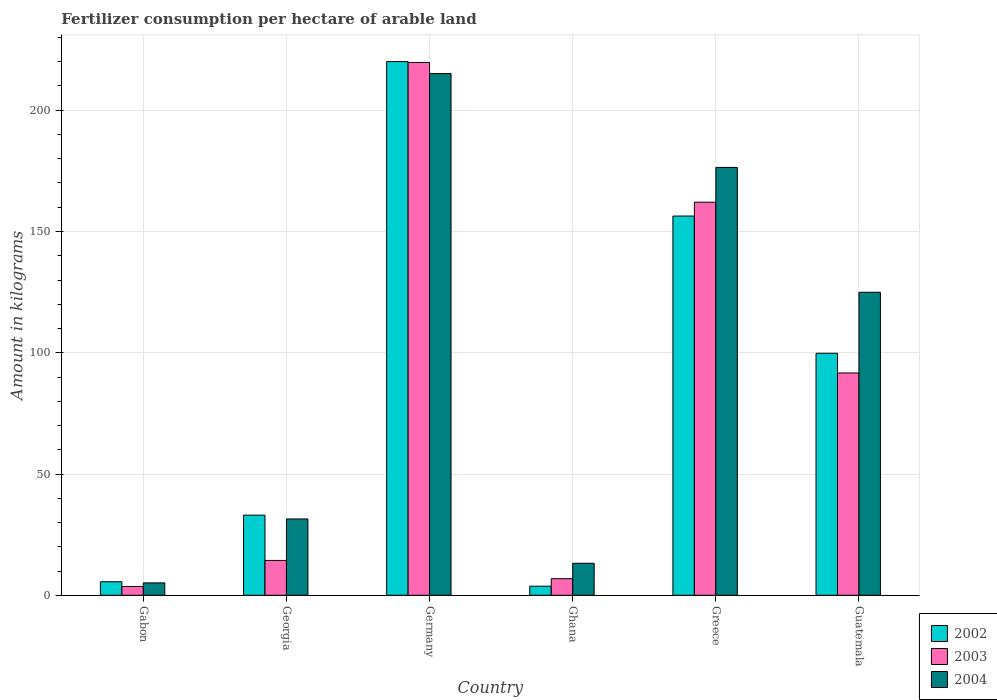How many different coloured bars are there?
Provide a succinct answer. 3. How many groups of bars are there?
Keep it short and to the point. 6. Are the number of bars on each tick of the X-axis equal?
Your response must be concise. Yes. What is the label of the 6th group of bars from the left?
Offer a terse response. Guatemala. What is the amount of fertilizer consumption in 2002 in Ghana?
Offer a terse response. 3.75. Across all countries, what is the maximum amount of fertilizer consumption in 2003?
Your answer should be compact. 219.7. Across all countries, what is the minimum amount of fertilizer consumption in 2003?
Keep it short and to the point. 3.61. In which country was the amount of fertilizer consumption in 2002 minimum?
Ensure brevity in your answer.  Ghana. What is the total amount of fertilizer consumption in 2004 in the graph?
Provide a short and direct response. 566.26. What is the difference between the amount of fertilizer consumption in 2004 in Georgia and that in Guatemala?
Your answer should be compact. -93.48. What is the difference between the amount of fertilizer consumption in 2004 in Ghana and the amount of fertilizer consumption in 2003 in Germany?
Offer a terse response. -206.5. What is the average amount of fertilizer consumption in 2002 per country?
Give a very brief answer. 86.43. What is the difference between the amount of fertilizer consumption of/in 2003 and amount of fertilizer consumption of/in 2002 in Gabon?
Provide a short and direct response. -1.97. What is the ratio of the amount of fertilizer consumption in 2004 in Gabon to that in Guatemala?
Your response must be concise. 0.04. Is the amount of fertilizer consumption in 2004 in Gabon less than that in Greece?
Provide a short and direct response. Yes. What is the difference between the highest and the second highest amount of fertilizer consumption in 2004?
Provide a succinct answer. 51.47. What is the difference between the highest and the lowest amount of fertilizer consumption in 2003?
Make the answer very short. 216.09. Is the sum of the amount of fertilizer consumption in 2004 in Ghana and Guatemala greater than the maximum amount of fertilizer consumption in 2003 across all countries?
Offer a very short reply. No. What does the 1st bar from the left in Gabon represents?
Your response must be concise. 2002. What does the 3rd bar from the right in Greece represents?
Offer a terse response. 2002. How many countries are there in the graph?
Ensure brevity in your answer.  6. Where does the legend appear in the graph?
Give a very brief answer. Bottom right. How many legend labels are there?
Make the answer very short. 3. What is the title of the graph?
Provide a short and direct response. Fertilizer consumption per hectare of arable land. Does "2012" appear as one of the legend labels in the graph?
Provide a short and direct response. No. What is the label or title of the Y-axis?
Provide a short and direct response. Amount in kilograms. What is the Amount in kilograms in 2002 in Gabon?
Your response must be concise. 5.58. What is the Amount in kilograms of 2003 in Gabon?
Keep it short and to the point. 3.61. What is the Amount in kilograms in 2004 in Gabon?
Your response must be concise. 5.11. What is the Amount in kilograms in 2002 in Georgia?
Your answer should be compact. 33.04. What is the Amount in kilograms of 2003 in Georgia?
Provide a succinct answer. 14.37. What is the Amount in kilograms of 2004 in Georgia?
Offer a terse response. 31.47. What is the Amount in kilograms in 2002 in Germany?
Offer a terse response. 220.07. What is the Amount in kilograms in 2003 in Germany?
Ensure brevity in your answer.  219.7. What is the Amount in kilograms of 2004 in Germany?
Your answer should be very brief. 215.13. What is the Amount in kilograms of 2002 in Ghana?
Your answer should be compact. 3.75. What is the Amount in kilograms in 2003 in Ghana?
Give a very brief answer. 6.84. What is the Amount in kilograms of 2004 in Ghana?
Keep it short and to the point. 13.2. What is the Amount in kilograms in 2002 in Greece?
Provide a short and direct response. 156.38. What is the Amount in kilograms of 2003 in Greece?
Give a very brief answer. 162.09. What is the Amount in kilograms of 2004 in Greece?
Offer a very short reply. 176.42. What is the Amount in kilograms in 2002 in Guatemala?
Your answer should be compact. 99.79. What is the Amount in kilograms of 2003 in Guatemala?
Your answer should be compact. 91.67. What is the Amount in kilograms in 2004 in Guatemala?
Make the answer very short. 124.95. Across all countries, what is the maximum Amount in kilograms in 2002?
Offer a very short reply. 220.07. Across all countries, what is the maximum Amount in kilograms in 2003?
Your answer should be compact. 219.7. Across all countries, what is the maximum Amount in kilograms of 2004?
Provide a succinct answer. 215.13. Across all countries, what is the minimum Amount in kilograms of 2002?
Provide a succinct answer. 3.75. Across all countries, what is the minimum Amount in kilograms of 2003?
Ensure brevity in your answer.  3.61. Across all countries, what is the minimum Amount in kilograms in 2004?
Your response must be concise. 5.11. What is the total Amount in kilograms of 2002 in the graph?
Your answer should be very brief. 518.61. What is the total Amount in kilograms of 2003 in the graph?
Your response must be concise. 498.28. What is the total Amount in kilograms of 2004 in the graph?
Offer a terse response. 566.26. What is the difference between the Amount in kilograms of 2002 in Gabon and that in Georgia?
Keep it short and to the point. -27.46. What is the difference between the Amount in kilograms in 2003 in Gabon and that in Georgia?
Ensure brevity in your answer.  -10.76. What is the difference between the Amount in kilograms in 2004 in Gabon and that in Georgia?
Keep it short and to the point. -26.36. What is the difference between the Amount in kilograms of 2002 in Gabon and that in Germany?
Offer a terse response. -214.5. What is the difference between the Amount in kilograms of 2003 in Gabon and that in Germany?
Keep it short and to the point. -216.09. What is the difference between the Amount in kilograms of 2004 in Gabon and that in Germany?
Your answer should be compact. -210.02. What is the difference between the Amount in kilograms in 2002 in Gabon and that in Ghana?
Offer a very short reply. 1.83. What is the difference between the Amount in kilograms of 2003 in Gabon and that in Ghana?
Offer a very short reply. -3.23. What is the difference between the Amount in kilograms of 2004 in Gabon and that in Ghana?
Make the answer very short. -8.09. What is the difference between the Amount in kilograms of 2002 in Gabon and that in Greece?
Give a very brief answer. -150.8. What is the difference between the Amount in kilograms of 2003 in Gabon and that in Greece?
Your answer should be very brief. -158.48. What is the difference between the Amount in kilograms of 2004 in Gabon and that in Greece?
Provide a succinct answer. -171.31. What is the difference between the Amount in kilograms of 2002 in Gabon and that in Guatemala?
Your answer should be very brief. -94.21. What is the difference between the Amount in kilograms of 2003 in Gabon and that in Guatemala?
Provide a short and direct response. -88.06. What is the difference between the Amount in kilograms in 2004 in Gabon and that in Guatemala?
Provide a short and direct response. -119.84. What is the difference between the Amount in kilograms of 2002 in Georgia and that in Germany?
Provide a short and direct response. -187.03. What is the difference between the Amount in kilograms in 2003 in Georgia and that in Germany?
Provide a short and direct response. -205.33. What is the difference between the Amount in kilograms in 2004 in Georgia and that in Germany?
Offer a very short reply. -183.66. What is the difference between the Amount in kilograms in 2002 in Georgia and that in Ghana?
Ensure brevity in your answer.  29.3. What is the difference between the Amount in kilograms of 2003 in Georgia and that in Ghana?
Provide a short and direct response. 7.53. What is the difference between the Amount in kilograms in 2004 in Georgia and that in Ghana?
Ensure brevity in your answer.  18.27. What is the difference between the Amount in kilograms in 2002 in Georgia and that in Greece?
Provide a short and direct response. -123.34. What is the difference between the Amount in kilograms of 2003 in Georgia and that in Greece?
Your answer should be very brief. -147.72. What is the difference between the Amount in kilograms of 2004 in Georgia and that in Greece?
Ensure brevity in your answer.  -144.95. What is the difference between the Amount in kilograms in 2002 in Georgia and that in Guatemala?
Your answer should be very brief. -66.75. What is the difference between the Amount in kilograms in 2003 in Georgia and that in Guatemala?
Your answer should be compact. -77.3. What is the difference between the Amount in kilograms in 2004 in Georgia and that in Guatemala?
Offer a very short reply. -93.48. What is the difference between the Amount in kilograms of 2002 in Germany and that in Ghana?
Give a very brief answer. 216.33. What is the difference between the Amount in kilograms in 2003 in Germany and that in Ghana?
Provide a short and direct response. 212.86. What is the difference between the Amount in kilograms of 2004 in Germany and that in Ghana?
Keep it short and to the point. 201.93. What is the difference between the Amount in kilograms of 2002 in Germany and that in Greece?
Offer a very short reply. 63.7. What is the difference between the Amount in kilograms in 2003 in Germany and that in Greece?
Provide a short and direct response. 57.61. What is the difference between the Amount in kilograms of 2004 in Germany and that in Greece?
Your answer should be compact. 38.71. What is the difference between the Amount in kilograms in 2002 in Germany and that in Guatemala?
Ensure brevity in your answer.  120.28. What is the difference between the Amount in kilograms of 2003 in Germany and that in Guatemala?
Keep it short and to the point. 128.03. What is the difference between the Amount in kilograms of 2004 in Germany and that in Guatemala?
Your answer should be very brief. 90.18. What is the difference between the Amount in kilograms in 2002 in Ghana and that in Greece?
Your answer should be compact. -152.63. What is the difference between the Amount in kilograms in 2003 in Ghana and that in Greece?
Your answer should be compact. -155.25. What is the difference between the Amount in kilograms of 2004 in Ghana and that in Greece?
Keep it short and to the point. -163.22. What is the difference between the Amount in kilograms of 2002 in Ghana and that in Guatemala?
Offer a very short reply. -96.04. What is the difference between the Amount in kilograms in 2003 in Ghana and that in Guatemala?
Provide a short and direct response. -84.83. What is the difference between the Amount in kilograms of 2004 in Ghana and that in Guatemala?
Ensure brevity in your answer.  -111.75. What is the difference between the Amount in kilograms of 2002 in Greece and that in Guatemala?
Ensure brevity in your answer.  56.59. What is the difference between the Amount in kilograms in 2003 in Greece and that in Guatemala?
Make the answer very short. 70.42. What is the difference between the Amount in kilograms of 2004 in Greece and that in Guatemala?
Your answer should be compact. 51.47. What is the difference between the Amount in kilograms in 2002 in Gabon and the Amount in kilograms in 2003 in Georgia?
Ensure brevity in your answer.  -8.79. What is the difference between the Amount in kilograms in 2002 in Gabon and the Amount in kilograms in 2004 in Georgia?
Give a very brief answer. -25.89. What is the difference between the Amount in kilograms of 2003 in Gabon and the Amount in kilograms of 2004 in Georgia?
Your answer should be compact. -27.85. What is the difference between the Amount in kilograms of 2002 in Gabon and the Amount in kilograms of 2003 in Germany?
Keep it short and to the point. -214.12. What is the difference between the Amount in kilograms in 2002 in Gabon and the Amount in kilograms in 2004 in Germany?
Your response must be concise. -209.55. What is the difference between the Amount in kilograms in 2003 in Gabon and the Amount in kilograms in 2004 in Germany?
Keep it short and to the point. -211.51. What is the difference between the Amount in kilograms in 2002 in Gabon and the Amount in kilograms in 2003 in Ghana?
Keep it short and to the point. -1.26. What is the difference between the Amount in kilograms in 2002 in Gabon and the Amount in kilograms in 2004 in Ghana?
Your answer should be very brief. -7.62. What is the difference between the Amount in kilograms in 2003 in Gabon and the Amount in kilograms in 2004 in Ghana?
Offer a very short reply. -9.59. What is the difference between the Amount in kilograms in 2002 in Gabon and the Amount in kilograms in 2003 in Greece?
Keep it short and to the point. -156.51. What is the difference between the Amount in kilograms in 2002 in Gabon and the Amount in kilograms in 2004 in Greece?
Offer a terse response. -170.84. What is the difference between the Amount in kilograms of 2003 in Gabon and the Amount in kilograms of 2004 in Greece?
Provide a succinct answer. -172.81. What is the difference between the Amount in kilograms in 2002 in Gabon and the Amount in kilograms in 2003 in Guatemala?
Ensure brevity in your answer.  -86.09. What is the difference between the Amount in kilograms of 2002 in Gabon and the Amount in kilograms of 2004 in Guatemala?
Your answer should be very brief. -119.37. What is the difference between the Amount in kilograms in 2003 in Gabon and the Amount in kilograms in 2004 in Guatemala?
Make the answer very short. -121.33. What is the difference between the Amount in kilograms of 2002 in Georgia and the Amount in kilograms of 2003 in Germany?
Provide a succinct answer. -186.66. What is the difference between the Amount in kilograms in 2002 in Georgia and the Amount in kilograms in 2004 in Germany?
Your answer should be very brief. -182.08. What is the difference between the Amount in kilograms in 2003 in Georgia and the Amount in kilograms in 2004 in Germany?
Offer a very short reply. -200.76. What is the difference between the Amount in kilograms of 2002 in Georgia and the Amount in kilograms of 2003 in Ghana?
Offer a very short reply. 26.2. What is the difference between the Amount in kilograms in 2002 in Georgia and the Amount in kilograms in 2004 in Ghana?
Offer a very short reply. 19.84. What is the difference between the Amount in kilograms in 2003 in Georgia and the Amount in kilograms in 2004 in Ghana?
Offer a very short reply. 1.17. What is the difference between the Amount in kilograms of 2002 in Georgia and the Amount in kilograms of 2003 in Greece?
Offer a terse response. -129.05. What is the difference between the Amount in kilograms of 2002 in Georgia and the Amount in kilograms of 2004 in Greece?
Provide a short and direct response. -143.38. What is the difference between the Amount in kilograms of 2003 in Georgia and the Amount in kilograms of 2004 in Greece?
Offer a terse response. -162.05. What is the difference between the Amount in kilograms of 2002 in Georgia and the Amount in kilograms of 2003 in Guatemala?
Give a very brief answer. -58.63. What is the difference between the Amount in kilograms in 2002 in Georgia and the Amount in kilograms in 2004 in Guatemala?
Your answer should be compact. -91.9. What is the difference between the Amount in kilograms in 2003 in Georgia and the Amount in kilograms in 2004 in Guatemala?
Your answer should be compact. -110.58. What is the difference between the Amount in kilograms of 2002 in Germany and the Amount in kilograms of 2003 in Ghana?
Make the answer very short. 213.24. What is the difference between the Amount in kilograms in 2002 in Germany and the Amount in kilograms in 2004 in Ghana?
Make the answer very short. 206.87. What is the difference between the Amount in kilograms of 2003 in Germany and the Amount in kilograms of 2004 in Ghana?
Provide a succinct answer. 206.5. What is the difference between the Amount in kilograms of 2002 in Germany and the Amount in kilograms of 2003 in Greece?
Give a very brief answer. 57.98. What is the difference between the Amount in kilograms of 2002 in Germany and the Amount in kilograms of 2004 in Greece?
Offer a very short reply. 43.66. What is the difference between the Amount in kilograms in 2003 in Germany and the Amount in kilograms in 2004 in Greece?
Make the answer very short. 43.28. What is the difference between the Amount in kilograms in 2002 in Germany and the Amount in kilograms in 2003 in Guatemala?
Offer a terse response. 128.4. What is the difference between the Amount in kilograms in 2002 in Germany and the Amount in kilograms in 2004 in Guatemala?
Offer a very short reply. 95.13. What is the difference between the Amount in kilograms in 2003 in Germany and the Amount in kilograms in 2004 in Guatemala?
Your answer should be compact. 94.75. What is the difference between the Amount in kilograms of 2002 in Ghana and the Amount in kilograms of 2003 in Greece?
Your response must be concise. -158.34. What is the difference between the Amount in kilograms in 2002 in Ghana and the Amount in kilograms in 2004 in Greece?
Your response must be concise. -172.67. What is the difference between the Amount in kilograms in 2003 in Ghana and the Amount in kilograms in 2004 in Greece?
Your answer should be compact. -169.58. What is the difference between the Amount in kilograms of 2002 in Ghana and the Amount in kilograms of 2003 in Guatemala?
Your answer should be very brief. -87.93. What is the difference between the Amount in kilograms of 2002 in Ghana and the Amount in kilograms of 2004 in Guatemala?
Make the answer very short. -121.2. What is the difference between the Amount in kilograms of 2003 in Ghana and the Amount in kilograms of 2004 in Guatemala?
Your response must be concise. -118.11. What is the difference between the Amount in kilograms in 2002 in Greece and the Amount in kilograms in 2003 in Guatemala?
Your answer should be very brief. 64.71. What is the difference between the Amount in kilograms of 2002 in Greece and the Amount in kilograms of 2004 in Guatemala?
Ensure brevity in your answer.  31.43. What is the difference between the Amount in kilograms of 2003 in Greece and the Amount in kilograms of 2004 in Guatemala?
Make the answer very short. 37.14. What is the average Amount in kilograms of 2002 per country?
Offer a terse response. 86.43. What is the average Amount in kilograms of 2003 per country?
Offer a terse response. 83.05. What is the average Amount in kilograms of 2004 per country?
Give a very brief answer. 94.38. What is the difference between the Amount in kilograms of 2002 and Amount in kilograms of 2003 in Gabon?
Your answer should be very brief. 1.97. What is the difference between the Amount in kilograms in 2002 and Amount in kilograms in 2004 in Gabon?
Make the answer very short. 0.47. What is the difference between the Amount in kilograms in 2003 and Amount in kilograms in 2004 in Gabon?
Your answer should be very brief. -1.5. What is the difference between the Amount in kilograms in 2002 and Amount in kilograms in 2003 in Georgia?
Your response must be concise. 18.67. What is the difference between the Amount in kilograms in 2002 and Amount in kilograms in 2004 in Georgia?
Provide a short and direct response. 1.57. What is the difference between the Amount in kilograms in 2003 and Amount in kilograms in 2004 in Georgia?
Offer a terse response. -17.1. What is the difference between the Amount in kilograms in 2002 and Amount in kilograms in 2003 in Germany?
Your response must be concise. 0.38. What is the difference between the Amount in kilograms in 2002 and Amount in kilograms in 2004 in Germany?
Your answer should be compact. 4.95. What is the difference between the Amount in kilograms in 2003 and Amount in kilograms in 2004 in Germany?
Keep it short and to the point. 4.57. What is the difference between the Amount in kilograms of 2002 and Amount in kilograms of 2003 in Ghana?
Make the answer very short. -3.09. What is the difference between the Amount in kilograms of 2002 and Amount in kilograms of 2004 in Ghana?
Make the answer very short. -9.46. What is the difference between the Amount in kilograms in 2003 and Amount in kilograms in 2004 in Ghana?
Provide a short and direct response. -6.36. What is the difference between the Amount in kilograms of 2002 and Amount in kilograms of 2003 in Greece?
Give a very brief answer. -5.71. What is the difference between the Amount in kilograms of 2002 and Amount in kilograms of 2004 in Greece?
Your answer should be compact. -20.04. What is the difference between the Amount in kilograms of 2003 and Amount in kilograms of 2004 in Greece?
Keep it short and to the point. -14.33. What is the difference between the Amount in kilograms in 2002 and Amount in kilograms in 2003 in Guatemala?
Offer a terse response. 8.12. What is the difference between the Amount in kilograms of 2002 and Amount in kilograms of 2004 in Guatemala?
Make the answer very short. -25.16. What is the difference between the Amount in kilograms in 2003 and Amount in kilograms in 2004 in Guatemala?
Give a very brief answer. -33.27. What is the ratio of the Amount in kilograms of 2002 in Gabon to that in Georgia?
Offer a terse response. 0.17. What is the ratio of the Amount in kilograms of 2003 in Gabon to that in Georgia?
Your answer should be compact. 0.25. What is the ratio of the Amount in kilograms of 2004 in Gabon to that in Georgia?
Provide a succinct answer. 0.16. What is the ratio of the Amount in kilograms of 2002 in Gabon to that in Germany?
Give a very brief answer. 0.03. What is the ratio of the Amount in kilograms in 2003 in Gabon to that in Germany?
Your answer should be very brief. 0.02. What is the ratio of the Amount in kilograms in 2004 in Gabon to that in Germany?
Your answer should be very brief. 0.02. What is the ratio of the Amount in kilograms of 2002 in Gabon to that in Ghana?
Provide a succinct answer. 1.49. What is the ratio of the Amount in kilograms of 2003 in Gabon to that in Ghana?
Provide a short and direct response. 0.53. What is the ratio of the Amount in kilograms of 2004 in Gabon to that in Ghana?
Make the answer very short. 0.39. What is the ratio of the Amount in kilograms in 2002 in Gabon to that in Greece?
Your response must be concise. 0.04. What is the ratio of the Amount in kilograms of 2003 in Gabon to that in Greece?
Ensure brevity in your answer.  0.02. What is the ratio of the Amount in kilograms in 2004 in Gabon to that in Greece?
Your answer should be compact. 0.03. What is the ratio of the Amount in kilograms of 2002 in Gabon to that in Guatemala?
Make the answer very short. 0.06. What is the ratio of the Amount in kilograms in 2003 in Gabon to that in Guatemala?
Make the answer very short. 0.04. What is the ratio of the Amount in kilograms in 2004 in Gabon to that in Guatemala?
Your response must be concise. 0.04. What is the ratio of the Amount in kilograms of 2002 in Georgia to that in Germany?
Provide a succinct answer. 0.15. What is the ratio of the Amount in kilograms in 2003 in Georgia to that in Germany?
Give a very brief answer. 0.07. What is the ratio of the Amount in kilograms in 2004 in Georgia to that in Germany?
Your response must be concise. 0.15. What is the ratio of the Amount in kilograms of 2002 in Georgia to that in Ghana?
Provide a succinct answer. 8.82. What is the ratio of the Amount in kilograms in 2003 in Georgia to that in Ghana?
Make the answer very short. 2.1. What is the ratio of the Amount in kilograms in 2004 in Georgia to that in Ghana?
Make the answer very short. 2.38. What is the ratio of the Amount in kilograms in 2002 in Georgia to that in Greece?
Keep it short and to the point. 0.21. What is the ratio of the Amount in kilograms of 2003 in Georgia to that in Greece?
Give a very brief answer. 0.09. What is the ratio of the Amount in kilograms of 2004 in Georgia to that in Greece?
Ensure brevity in your answer.  0.18. What is the ratio of the Amount in kilograms in 2002 in Georgia to that in Guatemala?
Provide a succinct answer. 0.33. What is the ratio of the Amount in kilograms in 2003 in Georgia to that in Guatemala?
Give a very brief answer. 0.16. What is the ratio of the Amount in kilograms of 2004 in Georgia to that in Guatemala?
Keep it short and to the point. 0.25. What is the ratio of the Amount in kilograms in 2002 in Germany to that in Ghana?
Your answer should be compact. 58.76. What is the ratio of the Amount in kilograms in 2003 in Germany to that in Ghana?
Your answer should be very brief. 32.12. What is the ratio of the Amount in kilograms in 2004 in Germany to that in Ghana?
Keep it short and to the point. 16.3. What is the ratio of the Amount in kilograms of 2002 in Germany to that in Greece?
Ensure brevity in your answer.  1.41. What is the ratio of the Amount in kilograms of 2003 in Germany to that in Greece?
Your response must be concise. 1.36. What is the ratio of the Amount in kilograms of 2004 in Germany to that in Greece?
Provide a succinct answer. 1.22. What is the ratio of the Amount in kilograms of 2002 in Germany to that in Guatemala?
Offer a terse response. 2.21. What is the ratio of the Amount in kilograms in 2003 in Germany to that in Guatemala?
Your answer should be very brief. 2.4. What is the ratio of the Amount in kilograms of 2004 in Germany to that in Guatemala?
Keep it short and to the point. 1.72. What is the ratio of the Amount in kilograms of 2002 in Ghana to that in Greece?
Ensure brevity in your answer.  0.02. What is the ratio of the Amount in kilograms of 2003 in Ghana to that in Greece?
Your answer should be very brief. 0.04. What is the ratio of the Amount in kilograms in 2004 in Ghana to that in Greece?
Provide a short and direct response. 0.07. What is the ratio of the Amount in kilograms in 2002 in Ghana to that in Guatemala?
Make the answer very short. 0.04. What is the ratio of the Amount in kilograms in 2003 in Ghana to that in Guatemala?
Your answer should be very brief. 0.07. What is the ratio of the Amount in kilograms of 2004 in Ghana to that in Guatemala?
Make the answer very short. 0.11. What is the ratio of the Amount in kilograms of 2002 in Greece to that in Guatemala?
Keep it short and to the point. 1.57. What is the ratio of the Amount in kilograms of 2003 in Greece to that in Guatemala?
Ensure brevity in your answer.  1.77. What is the ratio of the Amount in kilograms in 2004 in Greece to that in Guatemala?
Make the answer very short. 1.41. What is the difference between the highest and the second highest Amount in kilograms in 2002?
Keep it short and to the point. 63.7. What is the difference between the highest and the second highest Amount in kilograms in 2003?
Make the answer very short. 57.61. What is the difference between the highest and the second highest Amount in kilograms of 2004?
Give a very brief answer. 38.71. What is the difference between the highest and the lowest Amount in kilograms of 2002?
Provide a short and direct response. 216.33. What is the difference between the highest and the lowest Amount in kilograms in 2003?
Your answer should be very brief. 216.09. What is the difference between the highest and the lowest Amount in kilograms in 2004?
Keep it short and to the point. 210.02. 